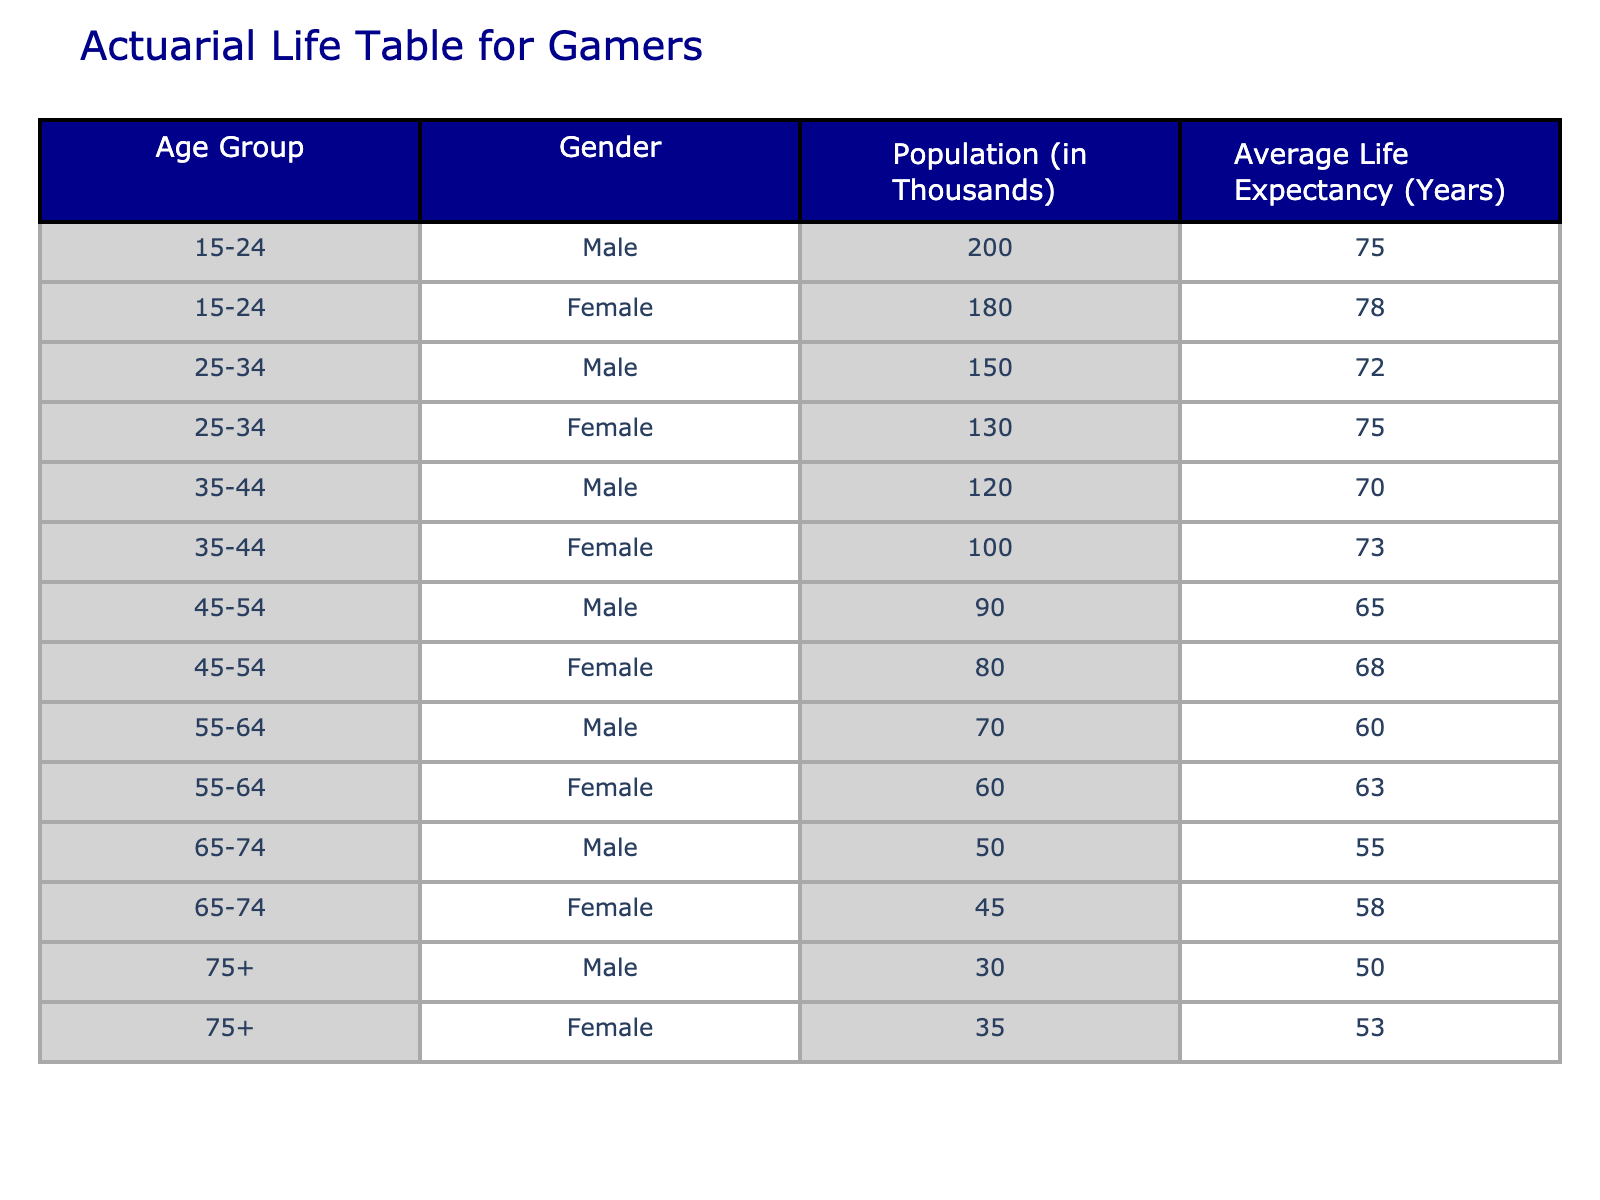What is the average life expectancy for females aged 15-24? The table shows that the average life expectancy for females in the 15-24 age group is 78 years.
Answer: 78 What is the total population of males and females aged 45-54 combined? The population for males aged 45-54 is 90 thousand and for females is 80 thousand. Adding these numbers gives 90 + 80 = 170 thousand.
Answer: 170 Which gender has a higher average life expectancy in the 55-64 age group? The average life expectancy for males is 60 years and for females is 63 years. Since 63 is greater than 60, females have a higher average life expectancy in this age group.
Answer: Females Is it true that the average life expectancy for males decreases with age? From the data, as age increases (from 15-24 to 75+), the average life expectancy for males decreases from 75 to 50 years. This indicates that the statement is true.
Answer: Yes What is the difference in average life expectancy between males and females in the 25-34 age group? For males, the average life expectancy is 72 years, and for females, it is 75 years. The difference is calculated as 75 - 72 = 3 years.
Answer: 3 